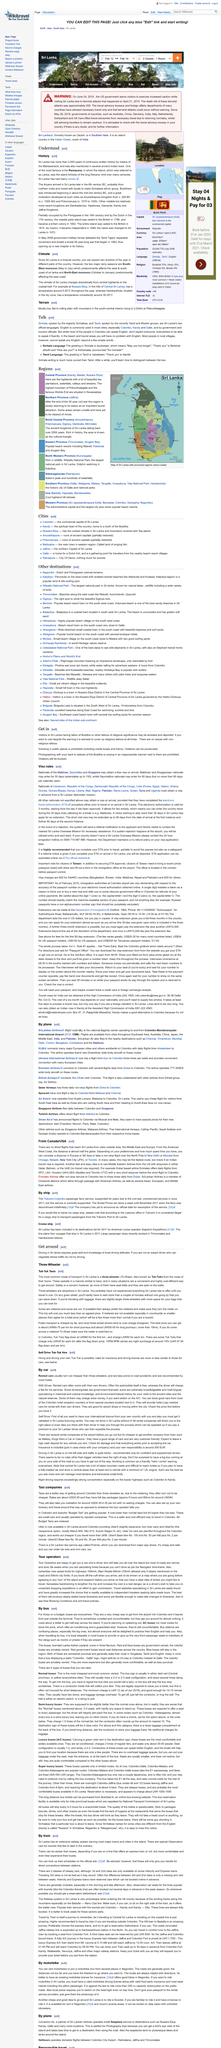Highlight a few significant elements in this photo. The Mahawansha is the document that contains 2,550 years of Sri Lanka's history, as stated in the document itself. The Aryans arrived in Sri Lanka late in the 6th century BC. Buddhism was introduced to Sri Lanka in approximately the mid-3rd century BC. 